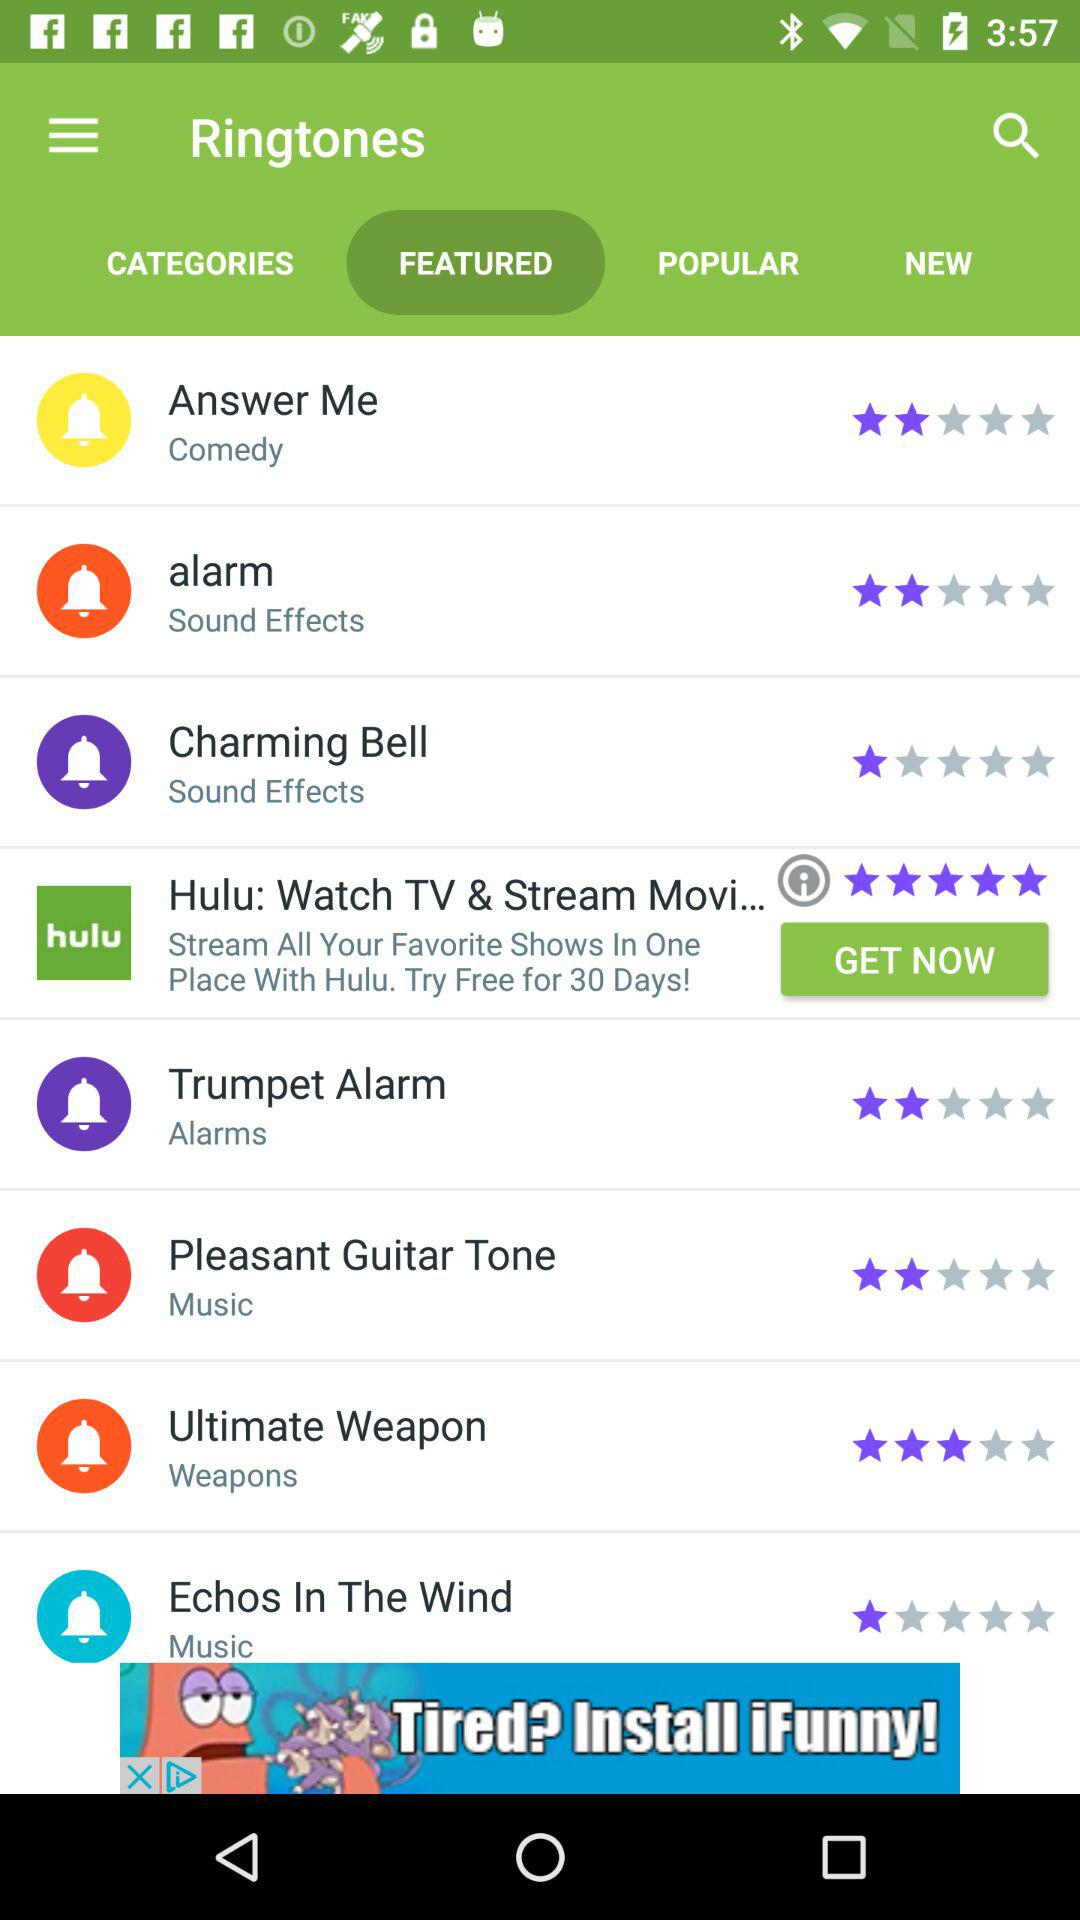How much is the rating of the "Charming Bell"? The rating is 1 star. 